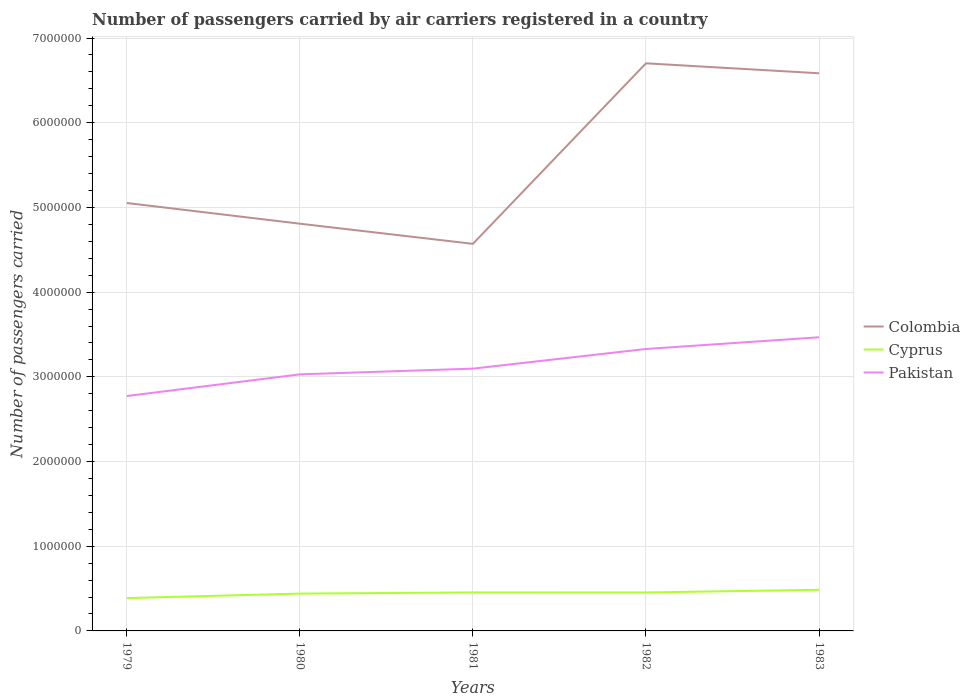Does the line corresponding to Colombia intersect with the line corresponding to Pakistan?
Give a very brief answer. No. Is the number of lines equal to the number of legend labels?
Make the answer very short. Yes. Across all years, what is the maximum number of passengers carried by air carriers in Colombia?
Your answer should be compact. 4.57e+06. What is the total number of passengers carried by air carriers in Pakistan in the graph?
Ensure brevity in your answer.  -2.32e+05. What is the difference between the highest and the second highest number of passengers carried by air carriers in Pakistan?
Ensure brevity in your answer.  6.94e+05. What is the difference between the highest and the lowest number of passengers carried by air carriers in Cyprus?
Provide a short and direct response. 3. Is the number of passengers carried by air carriers in Cyprus strictly greater than the number of passengers carried by air carriers in Pakistan over the years?
Make the answer very short. Yes. How many years are there in the graph?
Give a very brief answer. 5. Are the values on the major ticks of Y-axis written in scientific E-notation?
Provide a short and direct response. No. Does the graph contain grids?
Give a very brief answer. Yes. Where does the legend appear in the graph?
Your response must be concise. Center right. How many legend labels are there?
Offer a very short reply. 3. What is the title of the graph?
Offer a terse response. Number of passengers carried by air carriers registered in a country. What is the label or title of the X-axis?
Ensure brevity in your answer.  Years. What is the label or title of the Y-axis?
Your response must be concise. Number of passengers carried. What is the Number of passengers carried of Colombia in 1979?
Your answer should be very brief. 5.05e+06. What is the Number of passengers carried of Cyprus in 1979?
Your answer should be very brief. 3.88e+05. What is the Number of passengers carried of Pakistan in 1979?
Provide a short and direct response. 2.77e+06. What is the Number of passengers carried of Colombia in 1980?
Keep it short and to the point. 4.81e+06. What is the Number of passengers carried in Cyprus in 1980?
Make the answer very short. 4.41e+05. What is the Number of passengers carried of Pakistan in 1980?
Provide a short and direct response. 3.03e+06. What is the Number of passengers carried of Colombia in 1981?
Offer a terse response. 4.57e+06. What is the Number of passengers carried of Cyprus in 1981?
Ensure brevity in your answer.  4.55e+05. What is the Number of passengers carried in Pakistan in 1981?
Offer a terse response. 3.10e+06. What is the Number of passengers carried of Colombia in 1982?
Your answer should be very brief. 6.70e+06. What is the Number of passengers carried of Cyprus in 1982?
Offer a terse response. 4.54e+05. What is the Number of passengers carried of Pakistan in 1982?
Keep it short and to the point. 3.33e+06. What is the Number of passengers carried in Colombia in 1983?
Provide a short and direct response. 6.58e+06. What is the Number of passengers carried of Cyprus in 1983?
Offer a very short reply. 4.85e+05. What is the Number of passengers carried of Pakistan in 1983?
Your response must be concise. 3.47e+06. Across all years, what is the maximum Number of passengers carried of Colombia?
Provide a short and direct response. 6.70e+06. Across all years, what is the maximum Number of passengers carried in Cyprus?
Your answer should be very brief. 4.85e+05. Across all years, what is the maximum Number of passengers carried of Pakistan?
Provide a succinct answer. 3.47e+06. Across all years, what is the minimum Number of passengers carried of Colombia?
Keep it short and to the point. 4.57e+06. Across all years, what is the minimum Number of passengers carried in Cyprus?
Offer a terse response. 3.88e+05. Across all years, what is the minimum Number of passengers carried of Pakistan?
Offer a very short reply. 2.77e+06. What is the total Number of passengers carried of Colombia in the graph?
Provide a short and direct response. 2.77e+07. What is the total Number of passengers carried of Cyprus in the graph?
Keep it short and to the point. 2.22e+06. What is the total Number of passengers carried in Pakistan in the graph?
Make the answer very short. 1.57e+07. What is the difference between the Number of passengers carried of Colombia in 1979 and that in 1980?
Keep it short and to the point. 2.44e+05. What is the difference between the Number of passengers carried of Cyprus in 1979 and that in 1980?
Provide a succinct answer. -5.33e+04. What is the difference between the Number of passengers carried in Pakistan in 1979 and that in 1980?
Offer a terse response. -2.56e+05. What is the difference between the Number of passengers carried of Colombia in 1979 and that in 1981?
Make the answer very short. 4.82e+05. What is the difference between the Number of passengers carried of Cyprus in 1979 and that in 1981?
Keep it short and to the point. -6.75e+04. What is the difference between the Number of passengers carried in Pakistan in 1979 and that in 1981?
Offer a very short reply. -3.24e+05. What is the difference between the Number of passengers carried of Colombia in 1979 and that in 1982?
Your response must be concise. -1.65e+06. What is the difference between the Number of passengers carried of Cyprus in 1979 and that in 1982?
Make the answer very short. -6.68e+04. What is the difference between the Number of passengers carried of Pakistan in 1979 and that in 1982?
Your answer should be compact. -5.56e+05. What is the difference between the Number of passengers carried in Colombia in 1979 and that in 1983?
Your answer should be compact. -1.53e+06. What is the difference between the Number of passengers carried in Cyprus in 1979 and that in 1983?
Your answer should be very brief. -9.78e+04. What is the difference between the Number of passengers carried of Pakistan in 1979 and that in 1983?
Your answer should be very brief. -6.94e+05. What is the difference between the Number of passengers carried of Colombia in 1980 and that in 1981?
Offer a very short reply. 2.38e+05. What is the difference between the Number of passengers carried in Cyprus in 1980 and that in 1981?
Offer a very short reply. -1.42e+04. What is the difference between the Number of passengers carried of Pakistan in 1980 and that in 1981?
Your answer should be compact. -6.76e+04. What is the difference between the Number of passengers carried of Colombia in 1980 and that in 1982?
Your response must be concise. -1.89e+06. What is the difference between the Number of passengers carried of Cyprus in 1980 and that in 1982?
Make the answer very short. -1.35e+04. What is the difference between the Number of passengers carried of Pakistan in 1980 and that in 1982?
Your answer should be compact. -3.00e+05. What is the difference between the Number of passengers carried of Colombia in 1980 and that in 1983?
Your answer should be compact. -1.78e+06. What is the difference between the Number of passengers carried in Cyprus in 1980 and that in 1983?
Offer a very short reply. -4.45e+04. What is the difference between the Number of passengers carried in Pakistan in 1980 and that in 1983?
Provide a succinct answer. -4.38e+05. What is the difference between the Number of passengers carried in Colombia in 1981 and that in 1982?
Your response must be concise. -2.13e+06. What is the difference between the Number of passengers carried of Cyprus in 1981 and that in 1982?
Your answer should be compact. 700. What is the difference between the Number of passengers carried in Pakistan in 1981 and that in 1982?
Keep it short and to the point. -2.32e+05. What is the difference between the Number of passengers carried in Colombia in 1981 and that in 1983?
Your response must be concise. -2.01e+06. What is the difference between the Number of passengers carried of Cyprus in 1981 and that in 1983?
Your response must be concise. -3.03e+04. What is the difference between the Number of passengers carried of Pakistan in 1981 and that in 1983?
Provide a succinct answer. -3.70e+05. What is the difference between the Number of passengers carried of Colombia in 1982 and that in 1983?
Make the answer very short. 1.18e+05. What is the difference between the Number of passengers carried of Cyprus in 1982 and that in 1983?
Make the answer very short. -3.10e+04. What is the difference between the Number of passengers carried of Pakistan in 1982 and that in 1983?
Make the answer very short. -1.38e+05. What is the difference between the Number of passengers carried of Colombia in 1979 and the Number of passengers carried of Cyprus in 1980?
Make the answer very short. 4.61e+06. What is the difference between the Number of passengers carried of Colombia in 1979 and the Number of passengers carried of Pakistan in 1980?
Make the answer very short. 2.02e+06. What is the difference between the Number of passengers carried in Cyprus in 1979 and the Number of passengers carried in Pakistan in 1980?
Ensure brevity in your answer.  -2.64e+06. What is the difference between the Number of passengers carried in Colombia in 1979 and the Number of passengers carried in Cyprus in 1981?
Give a very brief answer. 4.60e+06. What is the difference between the Number of passengers carried of Colombia in 1979 and the Number of passengers carried of Pakistan in 1981?
Offer a very short reply. 1.96e+06. What is the difference between the Number of passengers carried of Cyprus in 1979 and the Number of passengers carried of Pakistan in 1981?
Make the answer very short. -2.71e+06. What is the difference between the Number of passengers carried in Colombia in 1979 and the Number of passengers carried in Cyprus in 1982?
Provide a short and direct response. 4.60e+06. What is the difference between the Number of passengers carried in Colombia in 1979 and the Number of passengers carried in Pakistan in 1982?
Make the answer very short. 1.72e+06. What is the difference between the Number of passengers carried of Cyprus in 1979 and the Number of passengers carried of Pakistan in 1982?
Your response must be concise. -2.94e+06. What is the difference between the Number of passengers carried in Colombia in 1979 and the Number of passengers carried in Cyprus in 1983?
Keep it short and to the point. 4.57e+06. What is the difference between the Number of passengers carried of Colombia in 1979 and the Number of passengers carried of Pakistan in 1983?
Keep it short and to the point. 1.59e+06. What is the difference between the Number of passengers carried in Cyprus in 1979 and the Number of passengers carried in Pakistan in 1983?
Your response must be concise. -3.08e+06. What is the difference between the Number of passengers carried of Colombia in 1980 and the Number of passengers carried of Cyprus in 1981?
Your response must be concise. 4.35e+06. What is the difference between the Number of passengers carried of Colombia in 1980 and the Number of passengers carried of Pakistan in 1981?
Ensure brevity in your answer.  1.71e+06. What is the difference between the Number of passengers carried of Cyprus in 1980 and the Number of passengers carried of Pakistan in 1981?
Provide a succinct answer. -2.66e+06. What is the difference between the Number of passengers carried of Colombia in 1980 and the Number of passengers carried of Cyprus in 1982?
Make the answer very short. 4.35e+06. What is the difference between the Number of passengers carried in Colombia in 1980 and the Number of passengers carried in Pakistan in 1982?
Provide a short and direct response. 1.48e+06. What is the difference between the Number of passengers carried in Cyprus in 1980 and the Number of passengers carried in Pakistan in 1982?
Make the answer very short. -2.89e+06. What is the difference between the Number of passengers carried in Colombia in 1980 and the Number of passengers carried in Cyprus in 1983?
Offer a terse response. 4.32e+06. What is the difference between the Number of passengers carried in Colombia in 1980 and the Number of passengers carried in Pakistan in 1983?
Keep it short and to the point. 1.34e+06. What is the difference between the Number of passengers carried of Cyprus in 1980 and the Number of passengers carried of Pakistan in 1983?
Offer a terse response. -3.03e+06. What is the difference between the Number of passengers carried of Colombia in 1981 and the Number of passengers carried of Cyprus in 1982?
Give a very brief answer. 4.12e+06. What is the difference between the Number of passengers carried of Colombia in 1981 and the Number of passengers carried of Pakistan in 1982?
Offer a very short reply. 1.24e+06. What is the difference between the Number of passengers carried of Cyprus in 1981 and the Number of passengers carried of Pakistan in 1982?
Provide a short and direct response. -2.87e+06. What is the difference between the Number of passengers carried in Colombia in 1981 and the Number of passengers carried in Cyprus in 1983?
Give a very brief answer. 4.08e+06. What is the difference between the Number of passengers carried of Colombia in 1981 and the Number of passengers carried of Pakistan in 1983?
Make the answer very short. 1.10e+06. What is the difference between the Number of passengers carried of Cyprus in 1981 and the Number of passengers carried of Pakistan in 1983?
Ensure brevity in your answer.  -3.01e+06. What is the difference between the Number of passengers carried of Colombia in 1982 and the Number of passengers carried of Cyprus in 1983?
Your response must be concise. 6.22e+06. What is the difference between the Number of passengers carried in Colombia in 1982 and the Number of passengers carried in Pakistan in 1983?
Make the answer very short. 3.23e+06. What is the difference between the Number of passengers carried in Cyprus in 1982 and the Number of passengers carried in Pakistan in 1983?
Make the answer very short. -3.01e+06. What is the average Number of passengers carried of Colombia per year?
Keep it short and to the point. 5.54e+06. What is the average Number of passengers carried of Cyprus per year?
Your answer should be compact. 4.45e+05. What is the average Number of passengers carried of Pakistan per year?
Provide a succinct answer. 3.14e+06. In the year 1979, what is the difference between the Number of passengers carried in Colombia and Number of passengers carried in Cyprus?
Your answer should be compact. 4.66e+06. In the year 1979, what is the difference between the Number of passengers carried of Colombia and Number of passengers carried of Pakistan?
Offer a very short reply. 2.28e+06. In the year 1979, what is the difference between the Number of passengers carried in Cyprus and Number of passengers carried in Pakistan?
Provide a short and direct response. -2.39e+06. In the year 1980, what is the difference between the Number of passengers carried in Colombia and Number of passengers carried in Cyprus?
Your response must be concise. 4.37e+06. In the year 1980, what is the difference between the Number of passengers carried in Colombia and Number of passengers carried in Pakistan?
Provide a succinct answer. 1.78e+06. In the year 1980, what is the difference between the Number of passengers carried in Cyprus and Number of passengers carried in Pakistan?
Give a very brief answer. -2.59e+06. In the year 1981, what is the difference between the Number of passengers carried of Colombia and Number of passengers carried of Cyprus?
Give a very brief answer. 4.12e+06. In the year 1981, what is the difference between the Number of passengers carried of Colombia and Number of passengers carried of Pakistan?
Ensure brevity in your answer.  1.47e+06. In the year 1981, what is the difference between the Number of passengers carried in Cyprus and Number of passengers carried in Pakistan?
Ensure brevity in your answer.  -2.64e+06. In the year 1982, what is the difference between the Number of passengers carried in Colombia and Number of passengers carried in Cyprus?
Give a very brief answer. 6.25e+06. In the year 1982, what is the difference between the Number of passengers carried of Colombia and Number of passengers carried of Pakistan?
Ensure brevity in your answer.  3.37e+06. In the year 1982, what is the difference between the Number of passengers carried in Cyprus and Number of passengers carried in Pakistan?
Offer a terse response. -2.87e+06. In the year 1983, what is the difference between the Number of passengers carried of Colombia and Number of passengers carried of Cyprus?
Make the answer very short. 6.10e+06. In the year 1983, what is the difference between the Number of passengers carried of Colombia and Number of passengers carried of Pakistan?
Your answer should be compact. 3.12e+06. In the year 1983, what is the difference between the Number of passengers carried of Cyprus and Number of passengers carried of Pakistan?
Keep it short and to the point. -2.98e+06. What is the ratio of the Number of passengers carried of Colombia in 1979 to that in 1980?
Keep it short and to the point. 1.05. What is the ratio of the Number of passengers carried in Cyprus in 1979 to that in 1980?
Ensure brevity in your answer.  0.88. What is the ratio of the Number of passengers carried of Pakistan in 1979 to that in 1980?
Your answer should be very brief. 0.92. What is the ratio of the Number of passengers carried of Colombia in 1979 to that in 1981?
Your answer should be compact. 1.11. What is the ratio of the Number of passengers carried of Cyprus in 1979 to that in 1981?
Offer a very short reply. 0.85. What is the ratio of the Number of passengers carried in Pakistan in 1979 to that in 1981?
Your response must be concise. 0.9. What is the ratio of the Number of passengers carried in Colombia in 1979 to that in 1982?
Your response must be concise. 0.75. What is the ratio of the Number of passengers carried of Cyprus in 1979 to that in 1982?
Give a very brief answer. 0.85. What is the ratio of the Number of passengers carried of Pakistan in 1979 to that in 1982?
Give a very brief answer. 0.83. What is the ratio of the Number of passengers carried in Colombia in 1979 to that in 1983?
Offer a terse response. 0.77. What is the ratio of the Number of passengers carried of Cyprus in 1979 to that in 1983?
Your answer should be very brief. 0.8. What is the ratio of the Number of passengers carried in Pakistan in 1979 to that in 1983?
Offer a terse response. 0.8. What is the ratio of the Number of passengers carried of Colombia in 1980 to that in 1981?
Your answer should be very brief. 1.05. What is the ratio of the Number of passengers carried in Cyprus in 1980 to that in 1981?
Your response must be concise. 0.97. What is the ratio of the Number of passengers carried of Pakistan in 1980 to that in 1981?
Provide a short and direct response. 0.98. What is the ratio of the Number of passengers carried in Colombia in 1980 to that in 1982?
Give a very brief answer. 0.72. What is the ratio of the Number of passengers carried of Cyprus in 1980 to that in 1982?
Keep it short and to the point. 0.97. What is the ratio of the Number of passengers carried in Pakistan in 1980 to that in 1982?
Keep it short and to the point. 0.91. What is the ratio of the Number of passengers carried in Colombia in 1980 to that in 1983?
Offer a terse response. 0.73. What is the ratio of the Number of passengers carried in Cyprus in 1980 to that in 1983?
Offer a terse response. 0.91. What is the ratio of the Number of passengers carried of Pakistan in 1980 to that in 1983?
Offer a very short reply. 0.87. What is the ratio of the Number of passengers carried of Colombia in 1981 to that in 1982?
Provide a succinct answer. 0.68. What is the ratio of the Number of passengers carried in Pakistan in 1981 to that in 1982?
Keep it short and to the point. 0.93. What is the ratio of the Number of passengers carried in Colombia in 1981 to that in 1983?
Your response must be concise. 0.69. What is the ratio of the Number of passengers carried in Cyprus in 1981 to that in 1983?
Provide a short and direct response. 0.94. What is the ratio of the Number of passengers carried in Pakistan in 1981 to that in 1983?
Offer a very short reply. 0.89. What is the ratio of the Number of passengers carried of Colombia in 1982 to that in 1983?
Make the answer very short. 1.02. What is the ratio of the Number of passengers carried of Cyprus in 1982 to that in 1983?
Provide a succinct answer. 0.94. What is the ratio of the Number of passengers carried of Pakistan in 1982 to that in 1983?
Provide a short and direct response. 0.96. What is the difference between the highest and the second highest Number of passengers carried of Colombia?
Provide a short and direct response. 1.18e+05. What is the difference between the highest and the second highest Number of passengers carried of Cyprus?
Ensure brevity in your answer.  3.03e+04. What is the difference between the highest and the second highest Number of passengers carried in Pakistan?
Give a very brief answer. 1.38e+05. What is the difference between the highest and the lowest Number of passengers carried of Colombia?
Keep it short and to the point. 2.13e+06. What is the difference between the highest and the lowest Number of passengers carried in Cyprus?
Give a very brief answer. 9.78e+04. What is the difference between the highest and the lowest Number of passengers carried in Pakistan?
Provide a succinct answer. 6.94e+05. 